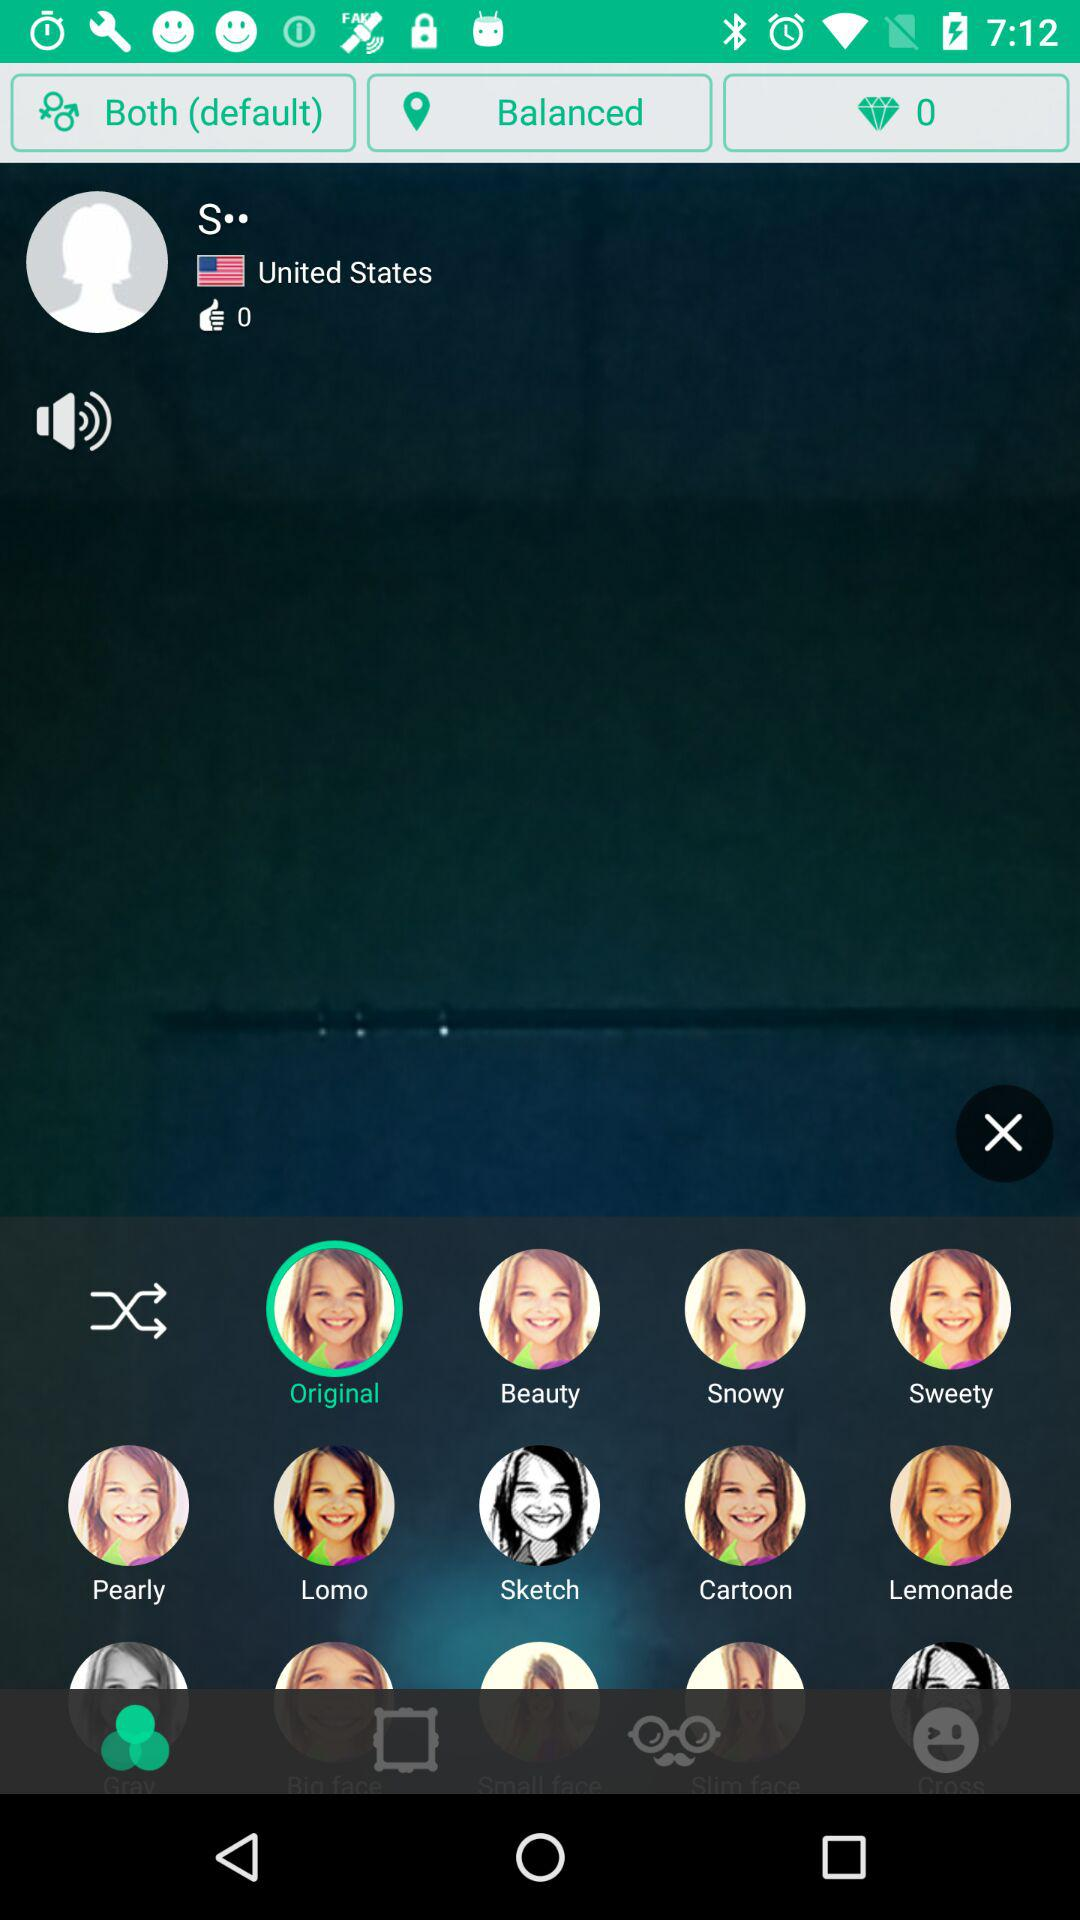What is the username? The username is "S··". 